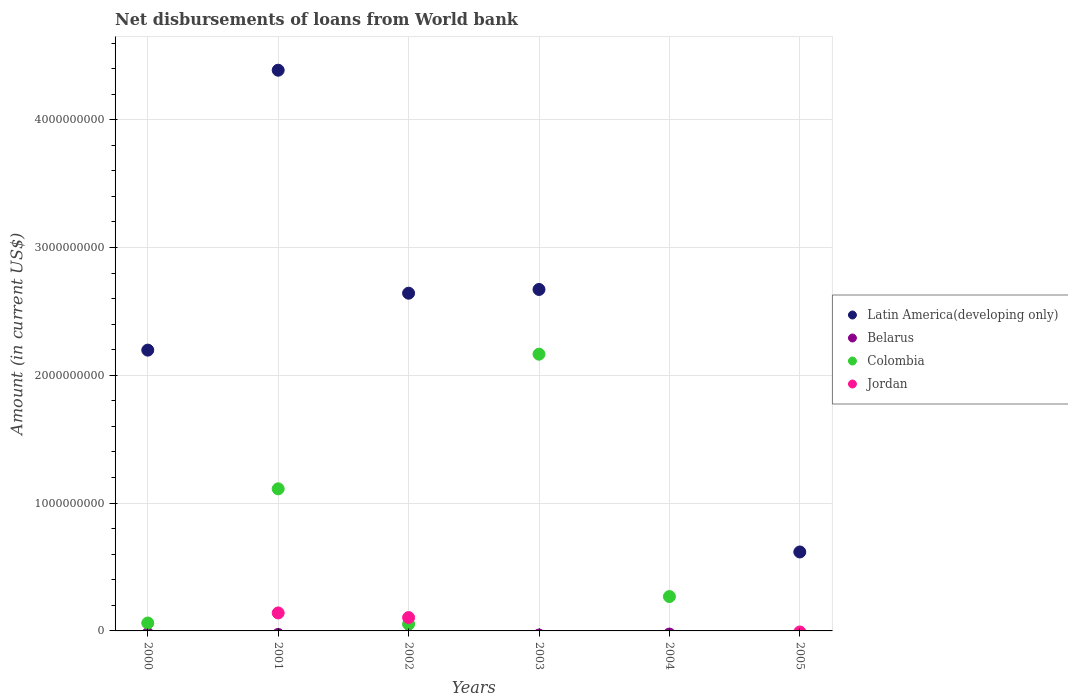How many different coloured dotlines are there?
Provide a short and direct response. 3. Is the number of dotlines equal to the number of legend labels?
Make the answer very short. No. What is the amount of loan disbursed from World Bank in Latin America(developing only) in 2004?
Give a very brief answer. 0. Across all years, what is the maximum amount of loan disbursed from World Bank in Latin America(developing only)?
Give a very brief answer. 4.39e+09. Across all years, what is the minimum amount of loan disbursed from World Bank in Jordan?
Ensure brevity in your answer.  0. In which year was the amount of loan disbursed from World Bank in Jordan maximum?
Your answer should be very brief. 2001. What is the total amount of loan disbursed from World Bank in Colombia in the graph?
Provide a succinct answer. 3.66e+09. What is the difference between the amount of loan disbursed from World Bank in Latin America(developing only) in 2000 and that in 2005?
Your answer should be compact. 1.58e+09. What is the difference between the amount of loan disbursed from World Bank in Colombia in 2004 and the amount of loan disbursed from World Bank in Jordan in 2002?
Your answer should be compact. 1.64e+08. What is the average amount of loan disbursed from World Bank in Latin America(developing only) per year?
Keep it short and to the point. 2.09e+09. In the year 2001, what is the difference between the amount of loan disbursed from World Bank in Jordan and amount of loan disbursed from World Bank in Colombia?
Provide a short and direct response. -9.71e+08. In how many years, is the amount of loan disbursed from World Bank in Latin America(developing only) greater than 1400000000 US$?
Provide a succinct answer. 4. What is the ratio of the amount of loan disbursed from World Bank in Colombia in 2003 to that in 2004?
Provide a short and direct response. 8.05. Is the amount of loan disbursed from World Bank in Colombia in 2000 less than that in 2001?
Provide a succinct answer. Yes. What is the difference between the highest and the second highest amount of loan disbursed from World Bank in Colombia?
Make the answer very short. 1.05e+09. What is the difference between the highest and the lowest amount of loan disbursed from World Bank in Colombia?
Provide a short and direct response. 2.17e+09. In how many years, is the amount of loan disbursed from World Bank in Belarus greater than the average amount of loan disbursed from World Bank in Belarus taken over all years?
Ensure brevity in your answer.  0. Is it the case that in every year, the sum of the amount of loan disbursed from World Bank in Jordan and amount of loan disbursed from World Bank in Latin America(developing only)  is greater than the sum of amount of loan disbursed from World Bank in Belarus and amount of loan disbursed from World Bank in Colombia?
Offer a very short reply. No. Is it the case that in every year, the sum of the amount of loan disbursed from World Bank in Belarus and amount of loan disbursed from World Bank in Latin America(developing only)  is greater than the amount of loan disbursed from World Bank in Jordan?
Your answer should be very brief. No. Does the amount of loan disbursed from World Bank in Belarus monotonically increase over the years?
Offer a very short reply. No. Is the amount of loan disbursed from World Bank in Belarus strictly greater than the amount of loan disbursed from World Bank in Latin America(developing only) over the years?
Make the answer very short. No. What is the difference between two consecutive major ticks on the Y-axis?
Keep it short and to the point. 1.00e+09. Are the values on the major ticks of Y-axis written in scientific E-notation?
Your answer should be very brief. No. What is the title of the graph?
Your answer should be very brief. Net disbursements of loans from World bank. Does "Cambodia" appear as one of the legend labels in the graph?
Keep it short and to the point. No. What is the label or title of the X-axis?
Keep it short and to the point. Years. What is the Amount (in current US$) of Latin America(developing only) in 2000?
Your answer should be compact. 2.20e+09. What is the Amount (in current US$) of Colombia in 2000?
Make the answer very short. 6.18e+07. What is the Amount (in current US$) of Latin America(developing only) in 2001?
Provide a succinct answer. 4.39e+09. What is the Amount (in current US$) of Colombia in 2001?
Your answer should be very brief. 1.11e+09. What is the Amount (in current US$) in Jordan in 2001?
Provide a succinct answer. 1.41e+08. What is the Amount (in current US$) in Latin America(developing only) in 2002?
Make the answer very short. 2.64e+09. What is the Amount (in current US$) in Colombia in 2002?
Offer a terse response. 5.33e+07. What is the Amount (in current US$) in Jordan in 2002?
Your response must be concise. 1.05e+08. What is the Amount (in current US$) of Latin America(developing only) in 2003?
Give a very brief answer. 2.67e+09. What is the Amount (in current US$) in Colombia in 2003?
Provide a short and direct response. 2.17e+09. What is the Amount (in current US$) of Latin America(developing only) in 2004?
Provide a succinct answer. 0. What is the Amount (in current US$) of Colombia in 2004?
Ensure brevity in your answer.  2.69e+08. What is the Amount (in current US$) in Latin America(developing only) in 2005?
Your answer should be very brief. 6.18e+08. What is the Amount (in current US$) in Belarus in 2005?
Give a very brief answer. 0. Across all years, what is the maximum Amount (in current US$) of Latin America(developing only)?
Your response must be concise. 4.39e+09. Across all years, what is the maximum Amount (in current US$) in Colombia?
Your answer should be compact. 2.17e+09. Across all years, what is the maximum Amount (in current US$) in Jordan?
Make the answer very short. 1.41e+08. Across all years, what is the minimum Amount (in current US$) in Colombia?
Make the answer very short. 0. Across all years, what is the minimum Amount (in current US$) of Jordan?
Offer a very short reply. 0. What is the total Amount (in current US$) in Latin America(developing only) in the graph?
Give a very brief answer. 1.25e+1. What is the total Amount (in current US$) in Colombia in the graph?
Your response must be concise. 3.66e+09. What is the total Amount (in current US$) in Jordan in the graph?
Your answer should be compact. 2.45e+08. What is the difference between the Amount (in current US$) in Latin America(developing only) in 2000 and that in 2001?
Offer a very short reply. -2.19e+09. What is the difference between the Amount (in current US$) in Colombia in 2000 and that in 2001?
Offer a very short reply. -1.05e+09. What is the difference between the Amount (in current US$) of Latin America(developing only) in 2000 and that in 2002?
Give a very brief answer. -4.45e+08. What is the difference between the Amount (in current US$) of Colombia in 2000 and that in 2002?
Offer a very short reply. 8.49e+06. What is the difference between the Amount (in current US$) of Latin America(developing only) in 2000 and that in 2003?
Your answer should be compact. -4.75e+08. What is the difference between the Amount (in current US$) of Colombia in 2000 and that in 2003?
Your response must be concise. -2.10e+09. What is the difference between the Amount (in current US$) of Colombia in 2000 and that in 2004?
Keep it short and to the point. -2.07e+08. What is the difference between the Amount (in current US$) of Latin America(developing only) in 2000 and that in 2005?
Offer a terse response. 1.58e+09. What is the difference between the Amount (in current US$) in Latin America(developing only) in 2001 and that in 2002?
Your answer should be compact. 1.74e+09. What is the difference between the Amount (in current US$) in Colombia in 2001 and that in 2002?
Your response must be concise. 1.06e+09. What is the difference between the Amount (in current US$) in Jordan in 2001 and that in 2002?
Provide a short and direct response. 3.62e+07. What is the difference between the Amount (in current US$) in Latin America(developing only) in 2001 and that in 2003?
Your response must be concise. 1.72e+09. What is the difference between the Amount (in current US$) of Colombia in 2001 and that in 2003?
Provide a short and direct response. -1.05e+09. What is the difference between the Amount (in current US$) of Colombia in 2001 and that in 2004?
Provide a short and direct response. 8.43e+08. What is the difference between the Amount (in current US$) of Latin America(developing only) in 2001 and that in 2005?
Ensure brevity in your answer.  3.77e+09. What is the difference between the Amount (in current US$) in Latin America(developing only) in 2002 and that in 2003?
Give a very brief answer. -2.93e+07. What is the difference between the Amount (in current US$) of Colombia in 2002 and that in 2003?
Keep it short and to the point. -2.11e+09. What is the difference between the Amount (in current US$) of Colombia in 2002 and that in 2004?
Your answer should be very brief. -2.16e+08. What is the difference between the Amount (in current US$) in Latin America(developing only) in 2002 and that in 2005?
Ensure brevity in your answer.  2.02e+09. What is the difference between the Amount (in current US$) of Colombia in 2003 and that in 2004?
Provide a short and direct response. 1.90e+09. What is the difference between the Amount (in current US$) in Latin America(developing only) in 2003 and that in 2005?
Offer a very short reply. 2.05e+09. What is the difference between the Amount (in current US$) of Latin America(developing only) in 2000 and the Amount (in current US$) of Colombia in 2001?
Your answer should be compact. 1.09e+09. What is the difference between the Amount (in current US$) in Latin America(developing only) in 2000 and the Amount (in current US$) in Jordan in 2001?
Make the answer very short. 2.06e+09. What is the difference between the Amount (in current US$) of Colombia in 2000 and the Amount (in current US$) of Jordan in 2001?
Your answer should be very brief. -7.89e+07. What is the difference between the Amount (in current US$) of Latin America(developing only) in 2000 and the Amount (in current US$) of Colombia in 2002?
Provide a succinct answer. 2.14e+09. What is the difference between the Amount (in current US$) in Latin America(developing only) in 2000 and the Amount (in current US$) in Jordan in 2002?
Ensure brevity in your answer.  2.09e+09. What is the difference between the Amount (in current US$) in Colombia in 2000 and the Amount (in current US$) in Jordan in 2002?
Provide a short and direct response. -4.27e+07. What is the difference between the Amount (in current US$) of Latin America(developing only) in 2000 and the Amount (in current US$) of Colombia in 2003?
Keep it short and to the point. 3.17e+07. What is the difference between the Amount (in current US$) of Latin America(developing only) in 2000 and the Amount (in current US$) of Colombia in 2004?
Your answer should be very brief. 1.93e+09. What is the difference between the Amount (in current US$) of Latin America(developing only) in 2001 and the Amount (in current US$) of Colombia in 2002?
Provide a succinct answer. 4.33e+09. What is the difference between the Amount (in current US$) in Latin America(developing only) in 2001 and the Amount (in current US$) in Jordan in 2002?
Your response must be concise. 4.28e+09. What is the difference between the Amount (in current US$) of Colombia in 2001 and the Amount (in current US$) of Jordan in 2002?
Your response must be concise. 1.01e+09. What is the difference between the Amount (in current US$) in Latin America(developing only) in 2001 and the Amount (in current US$) in Colombia in 2003?
Provide a short and direct response. 2.22e+09. What is the difference between the Amount (in current US$) of Latin America(developing only) in 2001 and the Amount (in current US$) of Colombia in 2004?
Your response must be concise. 4.12e+09. What is the difference between the Amount (in current US$) of Latin America(developing only) in 2002 and the Amount (in current US$) of Colombia in 2003?
Offer a very short reply. 4.77e+08. What is the difference between the Amount (in current US$) of Latin America(developing only) in 2002 and the Amount (in current US$) of Colombia in 2004?
Your answer should be very brief. 2.37e+09. What is the difference between the Amount (in current US$) of Latin America(developing only) in 2003 and the Amount (in current US$) of Colombia in 2004?
Your response must be concise. 2.40e+09. What is the average Amount (in current US$) of Latin America(developing only) per year?
Offer a very short reply. 2.09e+09. What is the average Amount (in current US$) of Belarus per year?
Provide a succinct answer. 0. What is the average Amount (in current US$) in Colombia per year?
Give a very brief answer. 6.10e+08. What is the average Amount (in current US$) of Jordan per year?
Offer a terse response. 4.09e+07. In the year 2000, what is the difference between the Amount (in current US$) of Latin America(developing only) and Amount (in current US$) of Colombia?
Ensure brevity in your answer.  2.14e+09. In the year 2001, what is the difference between the Amount (in current US$) in Latin America(developing only) and Amount (in current US$) in Colombia?
Make the answer very short. 3.28e+09. In the year 2001, what is the difference between the Amount (in current US$) in Latin America(developing only) and Amount (in current US$) in Jordan?
Offer a terse response. 4.25e+09. In the year 2001, what is the difference between the Amount (in current US$) of Colombia and Amount (in current US$) of Jordan?
Offer a terse response. 9.71e+08. In the year 2002, what is the difference between the Amount (in current US$) of Latin America(developing only) and Amount (in current US$) of Colombia?
Make the answer very short. 2.59e+09. In the year 2002, what is the difference between the Amount (in current US$) in Latin America(developing only) and Amount (in current US$) in Jordan?
Make the answer very short. 2.54e+09. In the year 2002, what is the difference between the Amount (in current US$) of Colombia and Amount (in current US$) of Jordan?
Your answer should be very brief. -5.12e+07. In the year 2003, what is the difference between the Amount (in current US$) in Latin America(developing only) and Amount (in current US$) in Colombia?
Make the answer very short. 5.06e+08. What is the ratio of the Amount (in current US$) in Latin America(developing only) in 2000 to that in 2001?
Offer a terse response. 0.5. What is the ratio of the Amount (in current US$) in Colombia in 2000 to that in 2001?
Provide a succinct answer. 0.06. What is the ratio of the Amount (in current US$) in Latin America(developing only) in 2000 to that in 2002?
Ensure brevity in your answer.  0.83. What is the ratio of the Amount (in current US$) of Colombia in 2000 to that in 2002?
Provide a short and direct response. 1.16. What is the ratio of the Amount (in current US$) of Latin America(developing only) in 2000 to that in 2003?
Make the answer very short. 0.82. What is the ratio of the Amount (in current US$) of Colombia in 2000 to that in 2003?
Ensure brevity in your answer.  0.03. What is the ratio of the Amount (in current US$) of Colombia in 2000 to that in 2004?
Your response must be concise. 0.23. What is the ratio of the Amount (in current US$) of Latin America(developing only) in 2000 to that in 2005?
Offer a very short reply. 3.56. What is the ratio of the Amount (in current US$) in Latin America(developing only) in 2001 to that in 2002?
Ensure brevity in your answer.  1.66. What is the ratio of the Amount (in current US$) in Colombia in 2001 to that in 2002?
Your response must be concise. 20.85. What is the ratio of the Amount (in current US$) in Jordan in 2001 to that in 2002?
Give a very brief answer. 1.35. What is the ratio of the Amount (in current US$) in Latin America(developing only) in 2001 to that in 2003?
Your answer should be compact. 1.64. What is the ratio of the Amount (in current US$) in Colombia in 2001 to that in 2003?
Ensure brevity in your answer.  0.51. What is the ratio of the Amount (in current US$) in Colombia in 2001 to that in 2004?
Give a very brief answer. 4.13. What is the ratio of the Amount (in current US$) of Latin America(developing only) in 2001 to that in 2005?
Provide a succinct answer. 7.1. What is the ratio of the Amount (in current US$) in Colombia in 2002 to that in 2003?
Make the answer very short. 0.02. What is the ratio of the Amount (in current US$) of Colombia in 2002 to that in 2004?
Keep it short and to the point. 0.2. What is the ratio of the Amount (in current US$) in Latin America(developing only) in 2002 to that in 2005?
Provide a short and direct response. 4.28. What is the ratio of the Amount (in current US$) in Colombia in 2003 to that in 2004?
Offer a very short reply. 8.05. What is the ratio of the Amount (in current US$) of Latin America(developing only) in 2003 to that in 2005?
Your response must be concise. 4.33. What is the difference between the highest and the second highest Amount (in current US$) of Latin America(developing only)?
Your answer should be compact. 1.72e+09. What is the difference between the highest and the second highest Amount (in current US$) in Colombia?
Provide a short and direct response. 1.05e+09. What is the difference between the highest and the lowest Amount (in current US$) in Latin America(developing only)?
Your answer should be compact. 4.39e+09. What is the difference between the highest and the lowest Amount (in current US$) in Colombia?
Make the answer very short. 2.17e+09. What is the difference between the highest and the lowest Amount (in current US$) of Jordan?
Keep it short and to the point. 1.41e+08. 